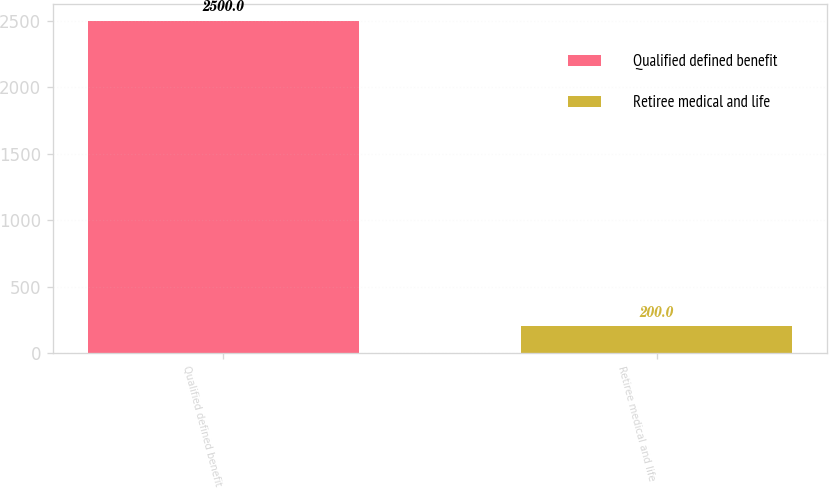<chart> <loc_0><loc_0><loc_500><loc_500><bar_chart><fcel>Qualified defined benefit<fcel>Retiree medical and life<nl><fcel>2500<fcel>200<nl></chart> 